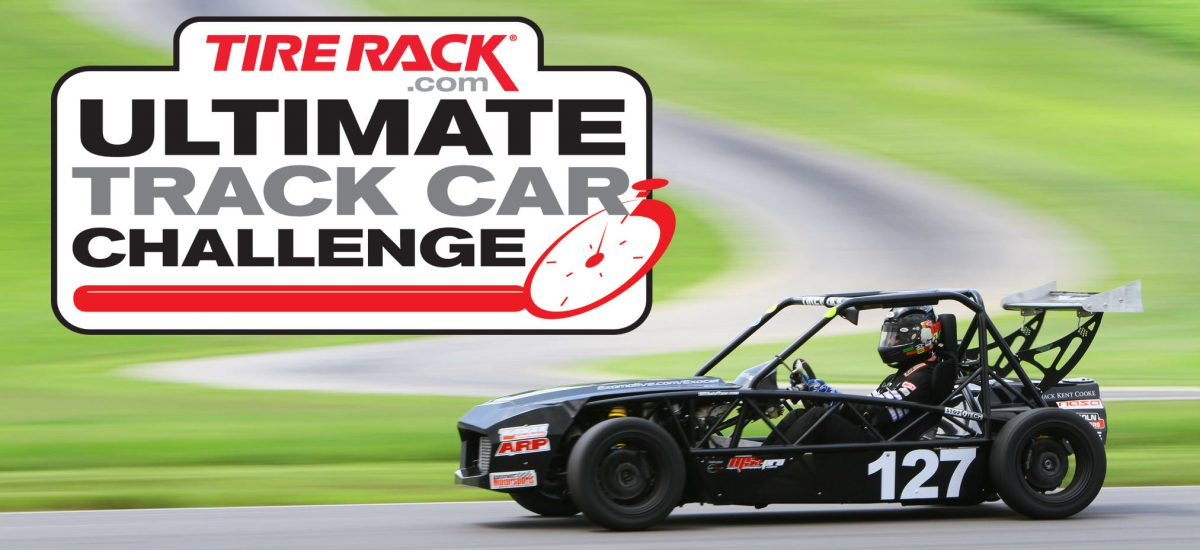What safety measures do such race cars typically incorporate? Safety is paramount in race car design. This car would be equipped with multiple safety features including a sturdy roll cage to protect the driver in the event of a rollover, a multi-point harness seatbelt system, fire suppression mechanisms, and impact-absorbing structures. A HANS (Head And Neck Support) device is also commonly used in conjunction with a helmet to reduce the risk of neck injuries during a crash. 